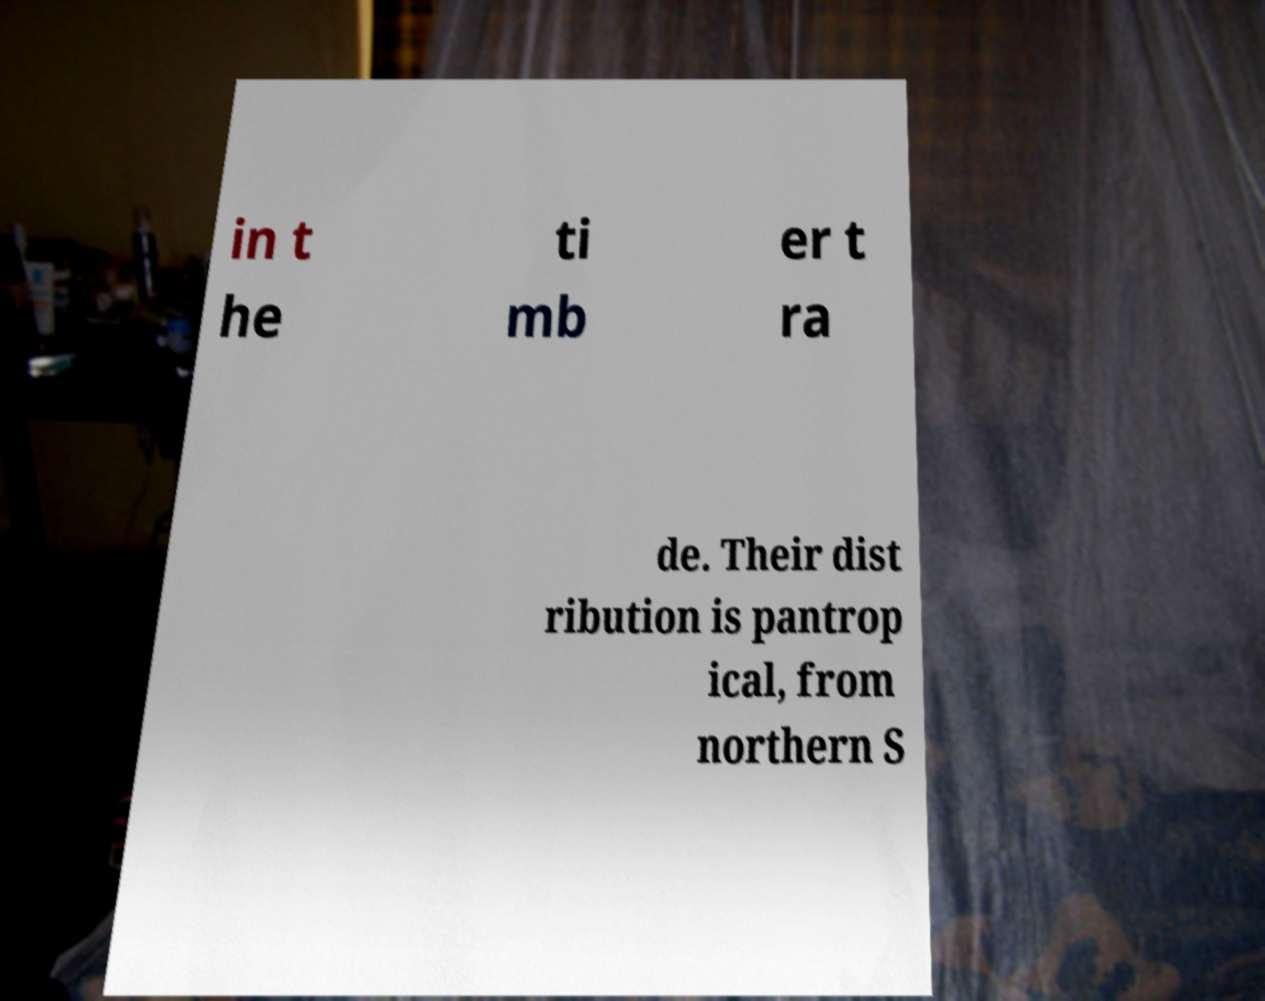Can you read and provide the text displayed in the image?This photo seems to have some interesting text. Can you extract and type it out for me? in t he ti mb er t ra de. Their dist ribution is pantrop ical, from northern S 